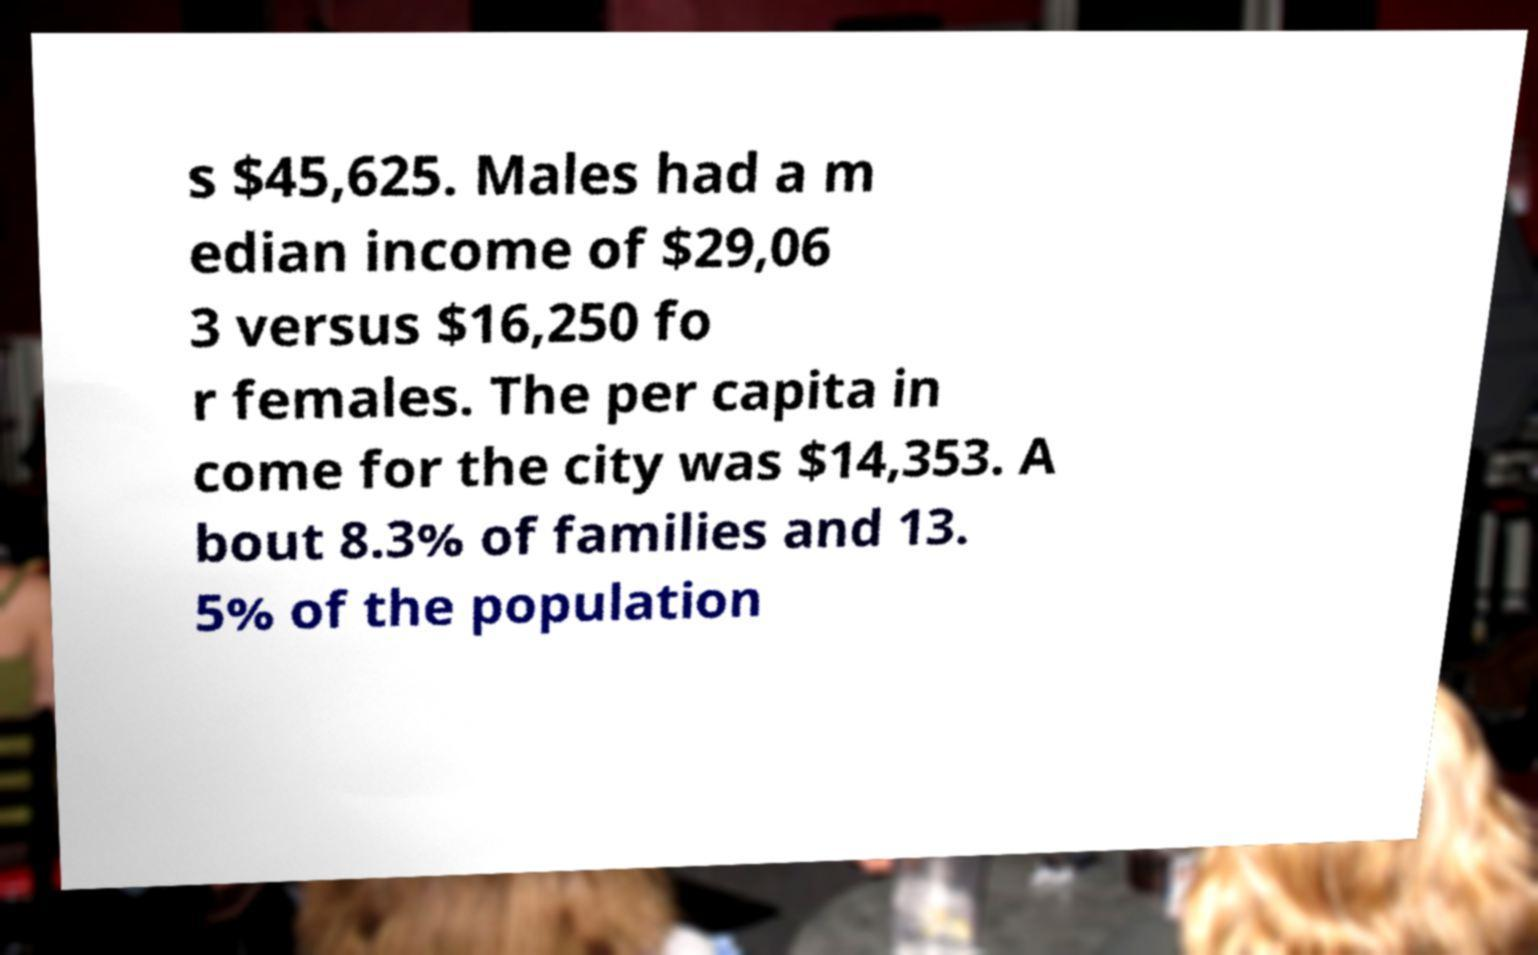Please read and relay the text visible in this image. What does it say? s $45,625. Males had a m edian income of $29,06 3 versus $16,250 fo r females. The per capita in come for the city was $14,353. A bout 8.3% of families and 13. 5% of the population 